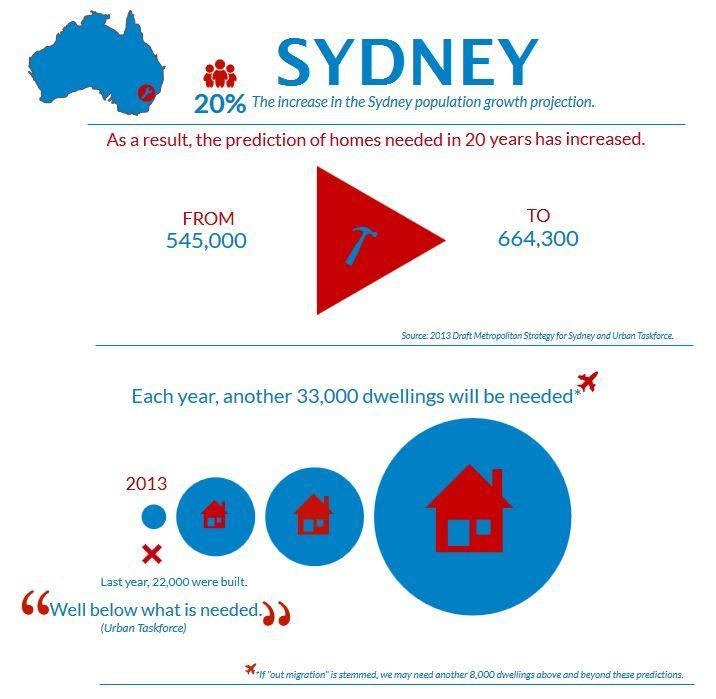What is the difference between the prediction of homes needed in 20 years?
Answer the question with a short phrase. 119300 